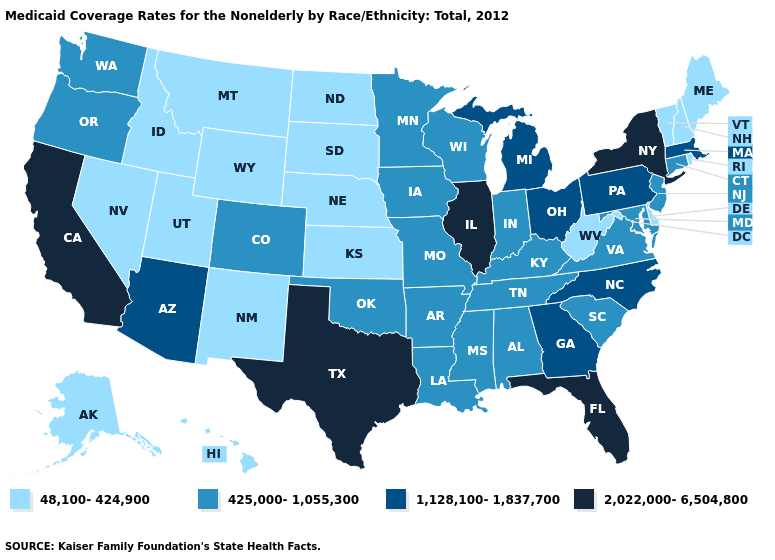Name the states that have a value in the range 425,000-1,055,300?
Give a very brief answer. Alabama, Arkansas, Colorado, Connecticut, Indiana, Iowa, Kentucky, Louisiana, Maryland, Minnesota, Mississippi, Missouri, New Jersey, Oklahoma, Oregon, South Carolina, Tennessee, Virginia, Washington, Wisconsin. What is the lowest value in the USA?
Be succinct. 48,100-424,900. Does the first symbol in the legend represent the smallest category?
Short answer required. Yes. What is the value of Minnesota?
Be succinct. 425,000-1,055,300. Which states have the highest value in the USA?
Write a very short answer. California, Florida, Illinois, New York, Texas. Does California have the lowest value in the USA?
Concise answer only. No. What is the value of South Dakota?
Write a very short answer. 48,100-424,900. What is the highest value in the South ?
Be succinct. 2,022,000-6,504,800. Does the first symbol in the legend represent the smallest category?
Write a very short answer. Yes. Name the states that have a value in the range 48,100-424,900?
Short answer required. Alaska, Delaware, Hawaii, Idaho, Kansas, Maine, Montana, Nebraska, Nevada, New Hampshire, New Mexico, North Dakota, Rhode Island, South Dakota, Utah, Vermont, West Virginia, Wyoming. Name the states that have a value in the range 2,022,000-6,504,800?
Short answer required. California, Florida, Illinois, New York, Texas. Among the states that border Maryland , does Pennsylvania have the highest value?
Write a very short answer. Yes. What is the value of Pennsylvania?
Keep it brief. 1,128,100-1,837,700. Does South Carolina have a higher value than Iowa?
Quick response, please. No. Name the states that have a value in the range 425,000-1,055,300?
Write a very short answer. Alabama, Arkansas, Colorado, Connecticut, Indiana, Iowa, Kentucky, Louisiana, Maryland, Minnesota, Mississippi, Missouri, New Jersey, Oklahoma, Oregon, South Carolina, Tennessee, Virginia, Washington, Wisconsin. 